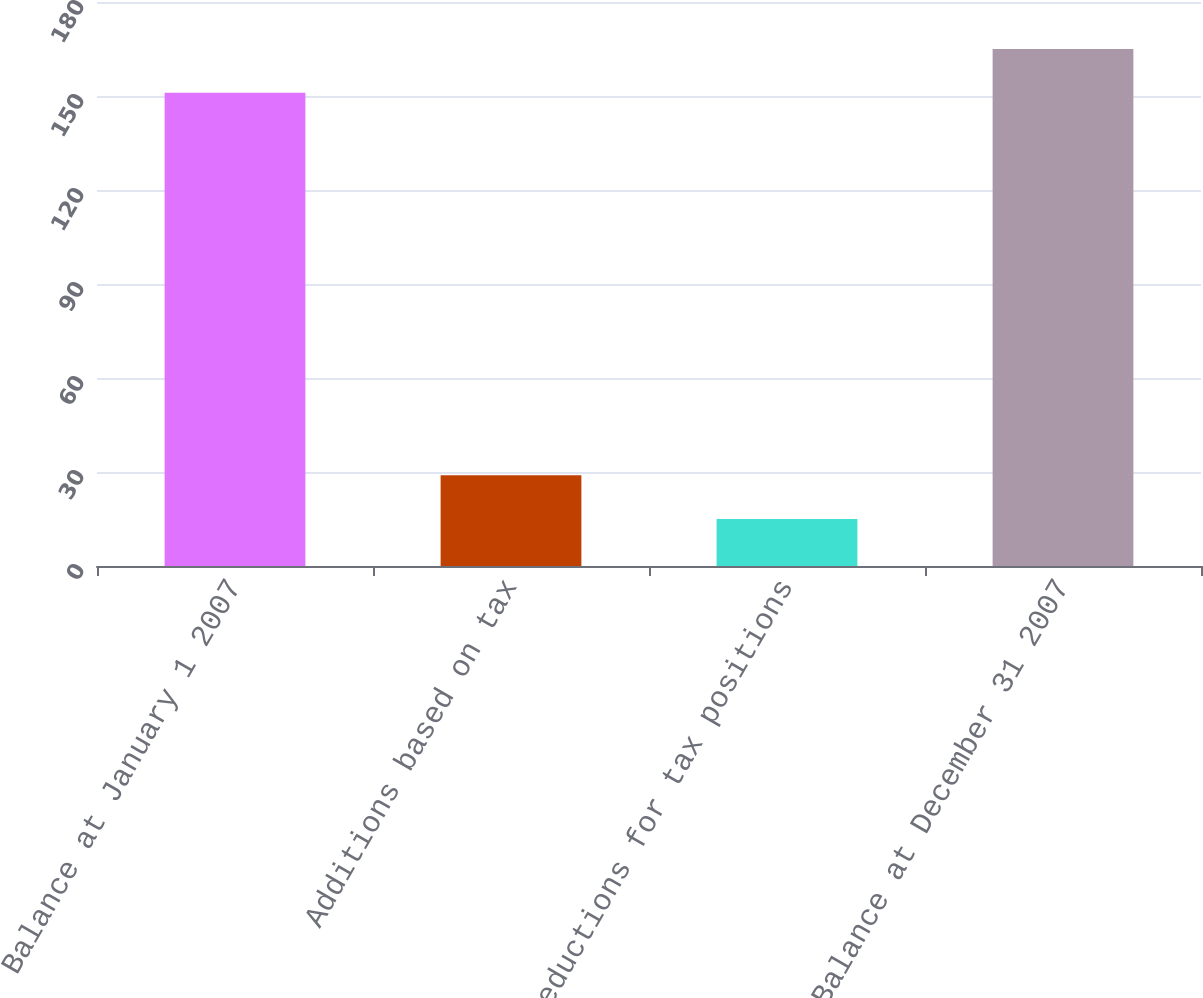<chart> <loc_0><loc_0><loc_500><loc_500><bar_chart><fcel>Balance at January 1 2007<fcel>Additions based on tax<fcel>Reductions for tax positions<fcel>Balance at December 31 2007<nl><fcel>151<fcel>29<fcel>15<fcel>165<nl></chart> 